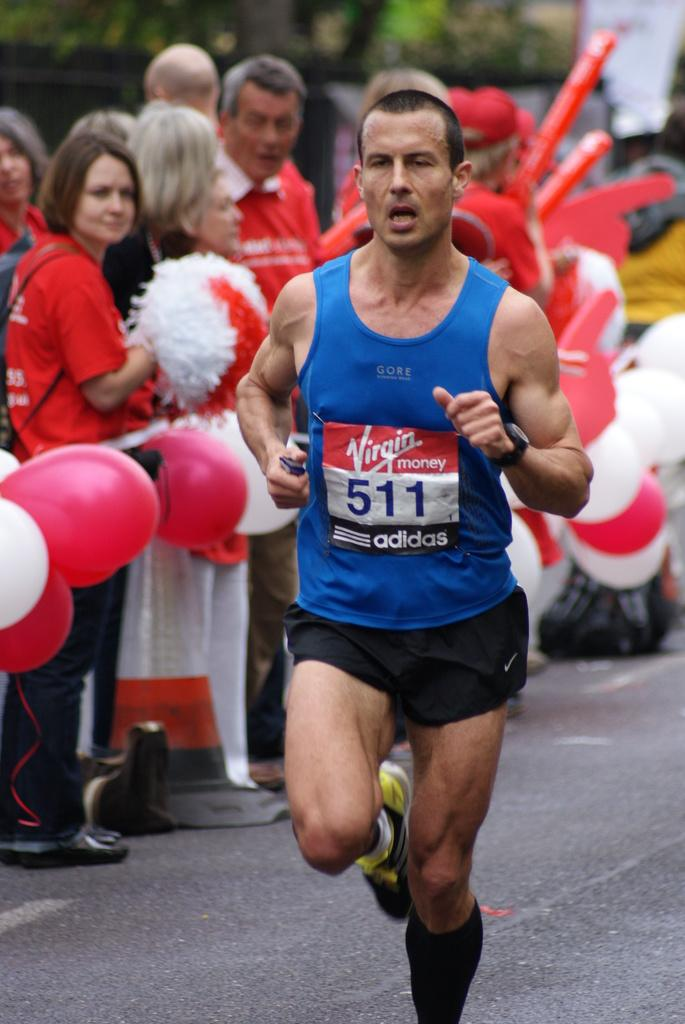<image>
Describe the image concisely. a man running with the number 511 on him 